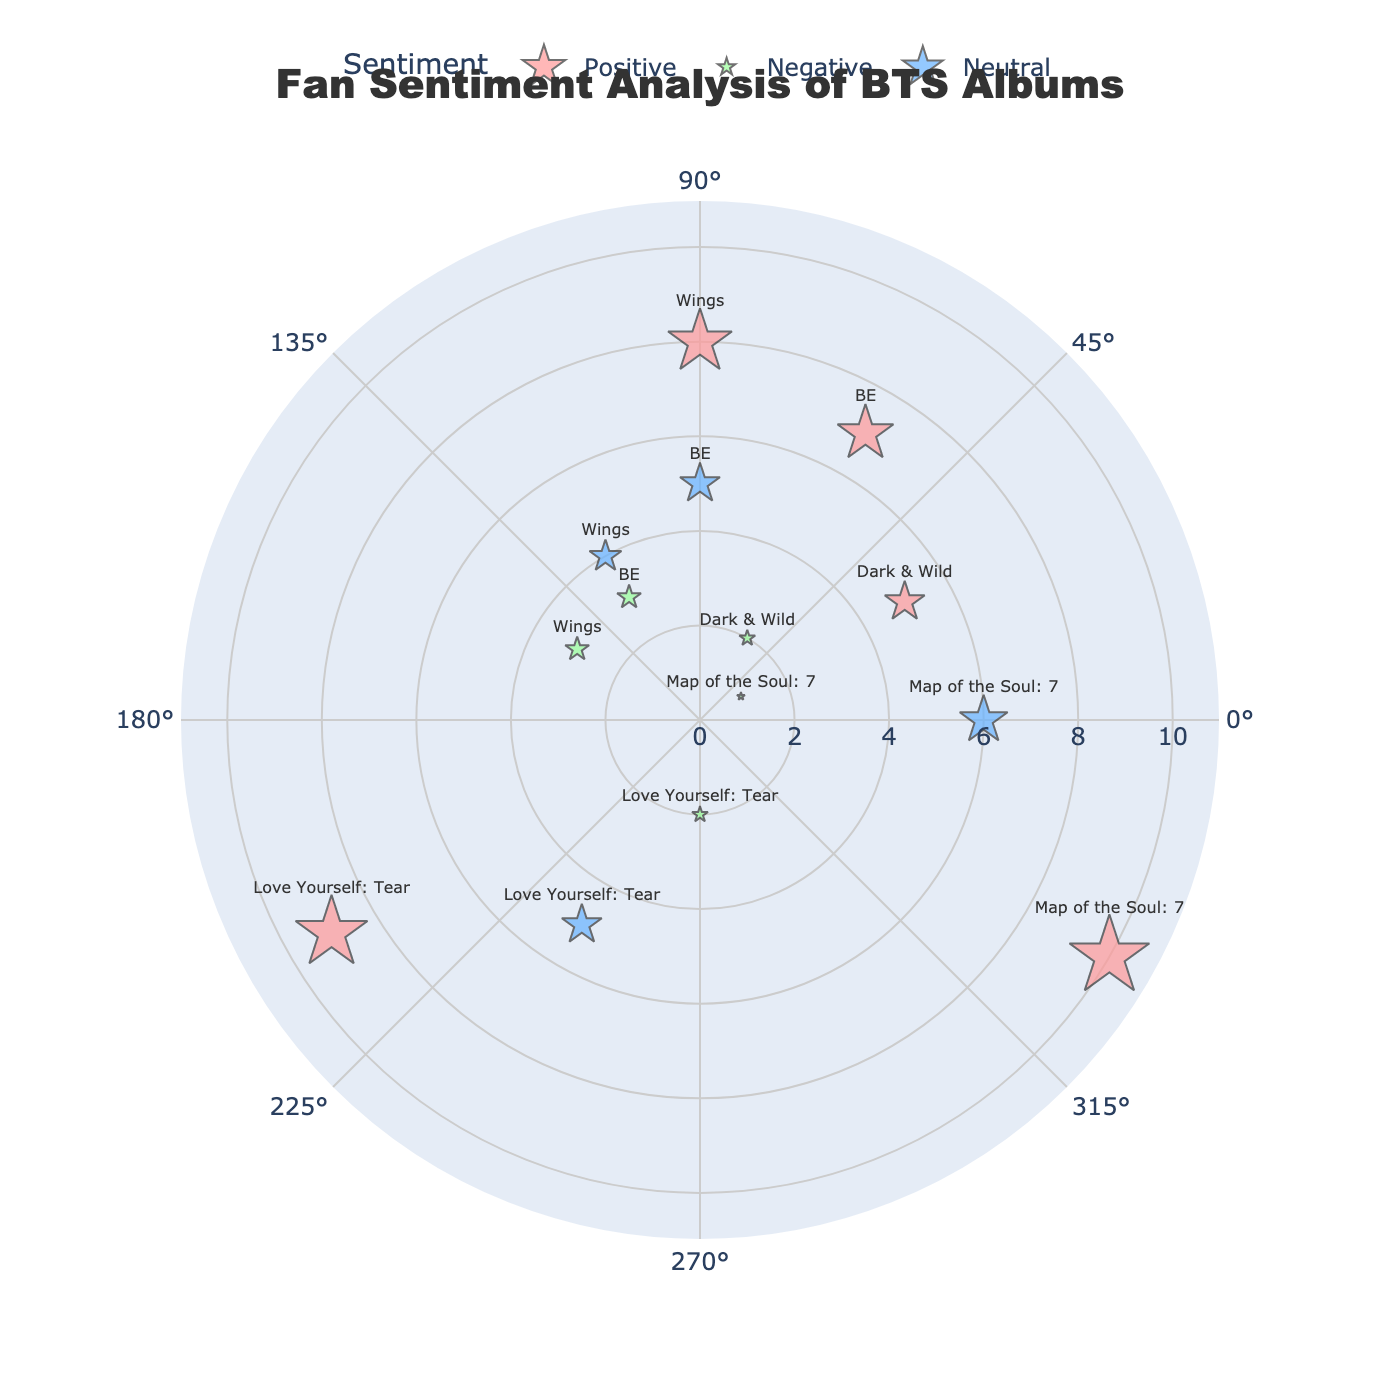what is the title of the chart? The title appears at the top of the chart and is usually in a larger font size. The title of this chart is "Fan Sentiment Analysis of BTS Albums".
Answer: Fan Sentiment Analysis of BTS Albums Which album has the highest positive sentiment score? By looking at the radial distance for Positive sentiment, the album with the highest distance (closest to the edge of the chart) is "Map of the Soul: 7".
Answer: Map of the Soul: 7 How many data points show a neutral sentiment? Neutral sentiment is represented by data points in blue. Counting the blue data points on the chart, we have three albums: “Wings”, “Love Yourself: Tear”, and “BE”.
Answer: 3 Which album has the smallest negative sentiment score? For Negative sentiment (green), look for the data point that is closest to the center. The smallest distance is 1, corresponding to “Map of the Soul: 7”.
Answer: Map of the Soul: 7 What is the average positive sentiment score of all albums? Adding all the distances for the Positive sentiment: 5 (Dark & Wild) + 8 (Wings) + 9 (Love Yourself: Tear) + 10 (Map of the Soul: 7) + 7 (BE) = 39. There are 5 albums, so the average is 39/5.
Answer: 7.8 Which sentiment is most common among "Wings" album? Look at the different distances for "Wings". Positive (8), Neutral (4), Negative (3). Positive has the highest distance value, indicating it is more common.
Answer: Positive Compare the negative sentiment scores between "Dark & Wild" and "Love Yourself: Tear" albums. Which one is greater? The distance for Negative sentiment of "Dark & Wild" is 2, while for "Love Yourself: Tear" it is also 2. Thus, they are equal.
Answer: Equal What is the sum of the neutral sentiment scores for all the albums? Summing up the distances for Neutral sentiment: 4 (Wings) + 5 (Love Yourself: Tear) + 6 (Map of the Soul: 7) + 5 (BE) = 20.
Answer: 20 Considering albums "Love Yourself: Tear" and "BE," which has a higher positive sentiment score? The Positive sentiment in “Love Yourself: Tear” is 9, whereas in “BE” it is 7.
Answer: Love Yourself: Tear How many albums have both positive and negative sentiment scores? "Dark & Wild", "Wings", "Love Yourself: Tear", "Map of the Soul: 7", and "BE" all have both positive and negative sentiment. That makes 5 albums.
Answer: 5 